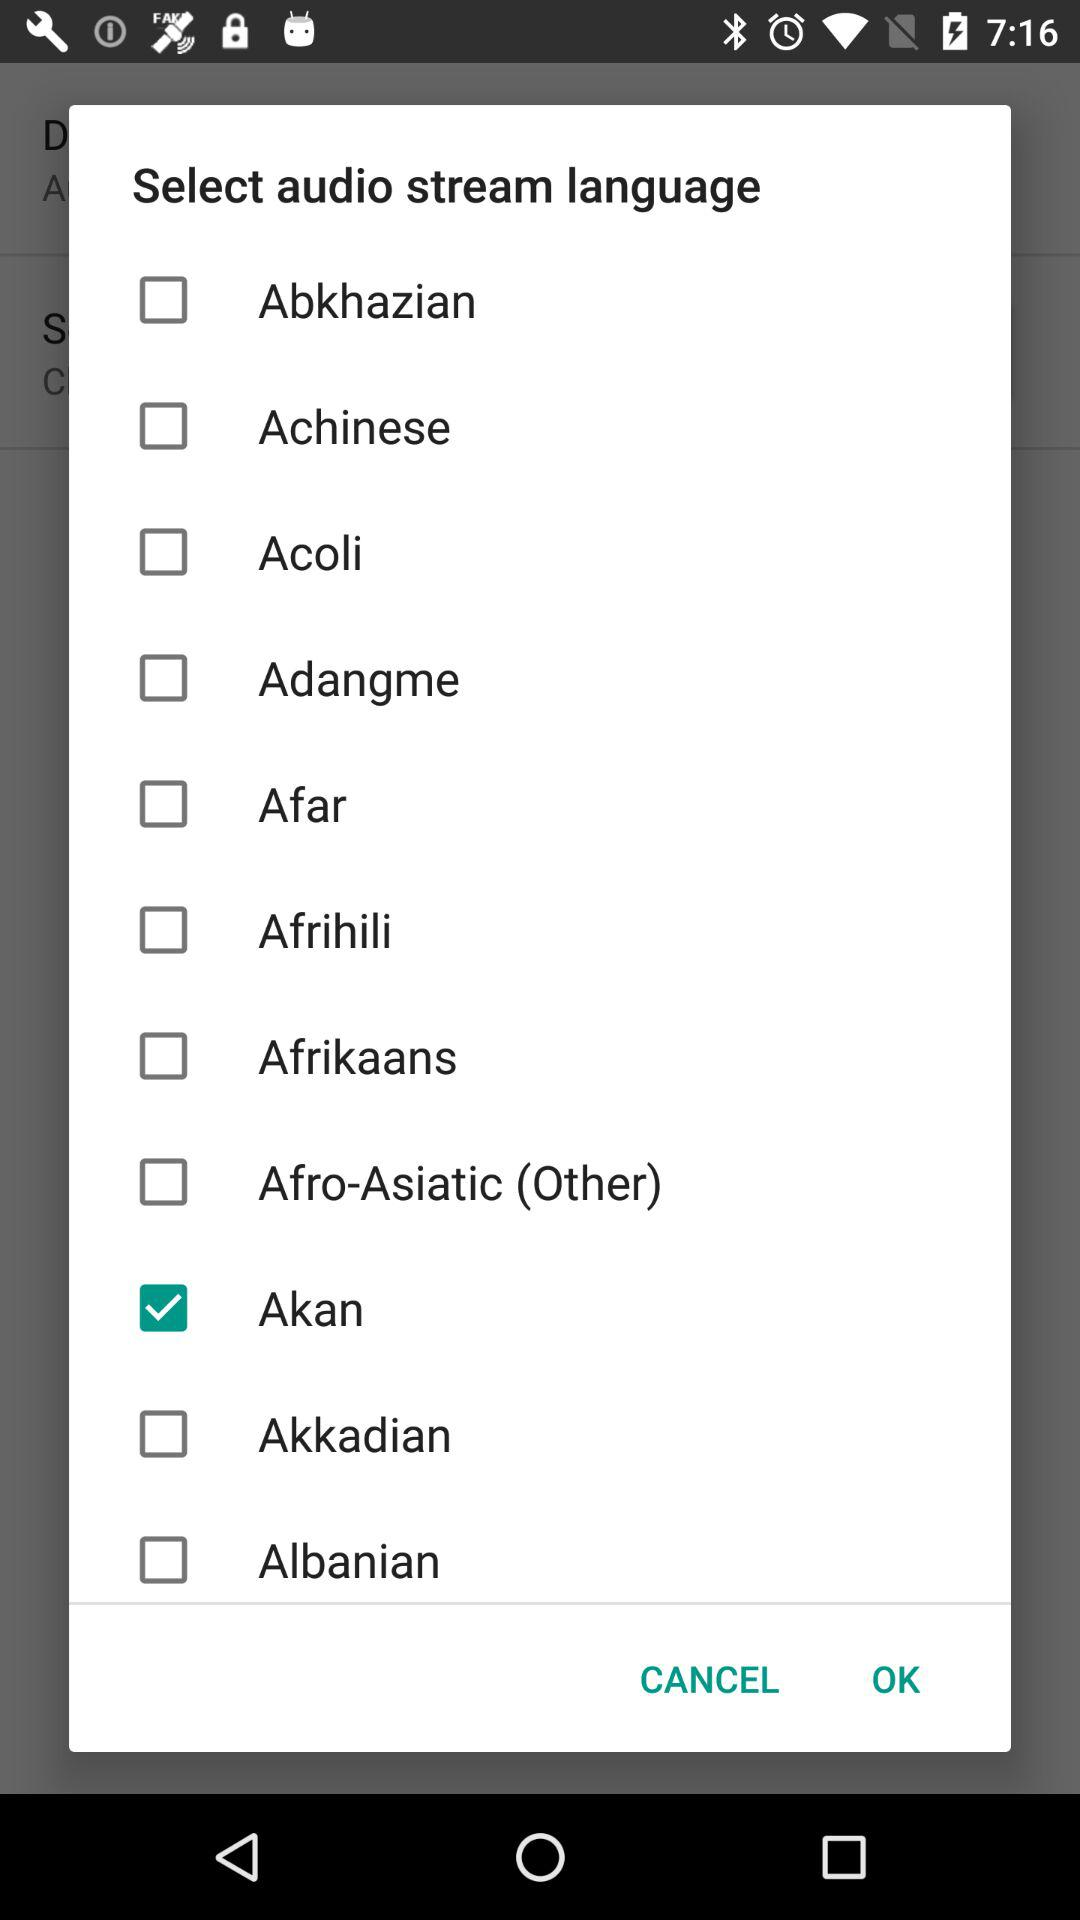Which option has been selected as the audio stream language? The selected option is "Akan". 